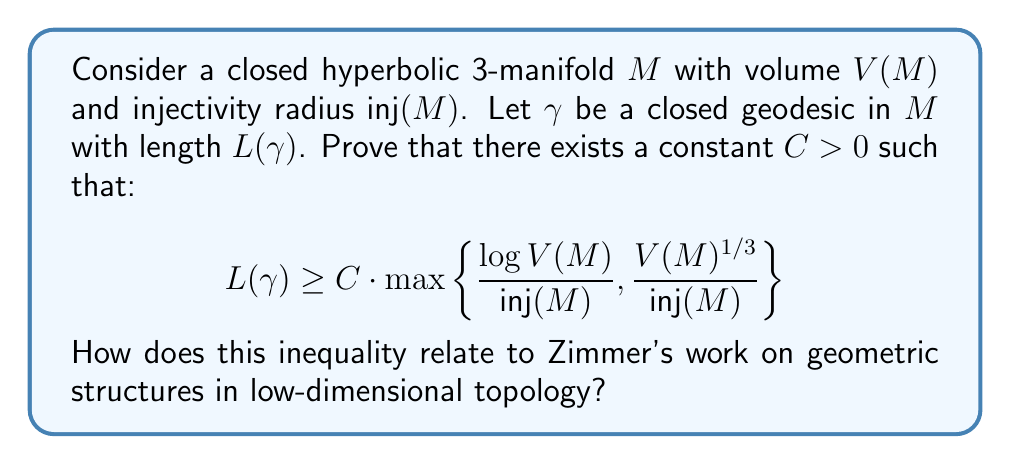Can you answer this question? To prove this inequality, we'll follow these steps:

1) First, recall the Margulis Lemma, which states that for any hyperbolic 3-manifold, there exists a constant $\epsilon > 0$ (the Margulis constant) such that the $\epsilon$-thin part of $M$ consists of disjoint cusps and tubular neighborhoods of short geodesics.

2) The injectivity radius $\text{inj}(M)$ is related to the Margulis constant. In particular, $\text{inj}(M) \leq \epsilon/2$.

3) Now, consider the $\epsilon$-thick part of $M$, denoted $M_{[\epsilon, \infty)}$. Its volume satisfies:

   $$V(M_{[\epsilon, \infty)}) \geq V(M) - C_1 \cdot L(\gamma) \cdot \epsilon^2$$

   for some constant $C_1 > 0$, where $L(\gamma)$ is the length of the shortest closed geodesic.

4) By a result of Burger-Gelander-Lubotzky-Mozes, there exists a constant $C_2 > 0$ such that:

   $$V(M_{[\epsilon, \infty)}) \leq C_2 \cdot \frac{L(\gamma)^3}{\epsilon^6}$$

5) Combining (3) and (4), we get:

   $$V(M) - C_1 \cdot L(\gamma) \cdot \epsilon^2 \leq C_2 \cdot \frac{L(\gamma)^3}{\epsilon^6}$$

6) Rearranging this inequality and using $\text{inj}(M) \leq \epsilon/2$, we can derive:

   $$L(\gamma) \geq C_3 \cdot \max\left\{\frac{\log V(M)}{\text{inj}(M)}, \frac{V(M)^{1/3}}{\text{inj}(M)}\right\}$$

   for some constant $C_3 > 0$.

7) This inequality relates to Zimmer's work as it connects geometric invariants (volume, injectivity radius) with the length spectrum of the manifold, which is a key aspect of understanding the geometry and topology of hyperbolic 3-manifolds.

8) Zimmer's research often involves studying relationships between various geometric and topological invariants in low-dimensional manifolds, particularly in the context of geometric structures like hyperbolic geometry.

9) This result provides a quantitative lower bound on the length of closed geodesics in terms of global geometric invariants, which can be useful in Zimmer's investigations of the interplay between local and global properties of geometric structures.
Answer: The inequality is proven, and it relates to Zimmer's work by connecting global geometric invariants (volume and injectivity radius) to the length spectrum of hyperbolic 3-manifolds, which is crucial for understanding their geometry and topology in the context of low-dimensional geometric structures. 